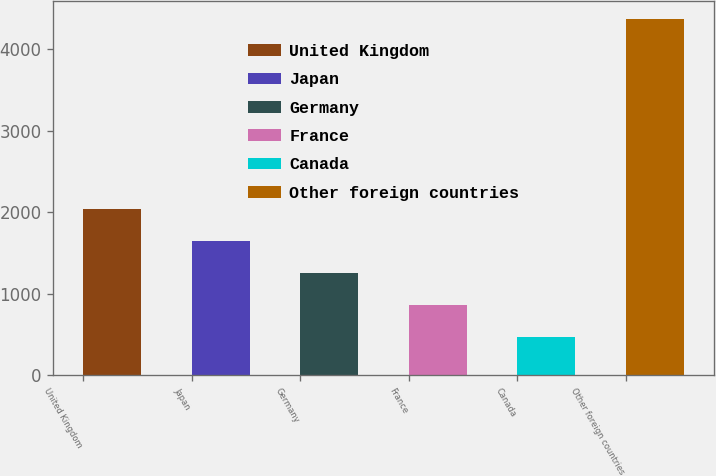Convert chart to OTSL. <chart><loc_0><loc_0><loc_500><loc_500><bar_chart><fcel>United Kingdom<fcel>Japan<fcel>Germany<fcel>France<fcel>Canada<fcel>Other foreign countries<nl><fcel>2034<fcel>1643.5<fcel>1253<fcel>862.5<fcel>472<fcel>4377<nl></chart> 